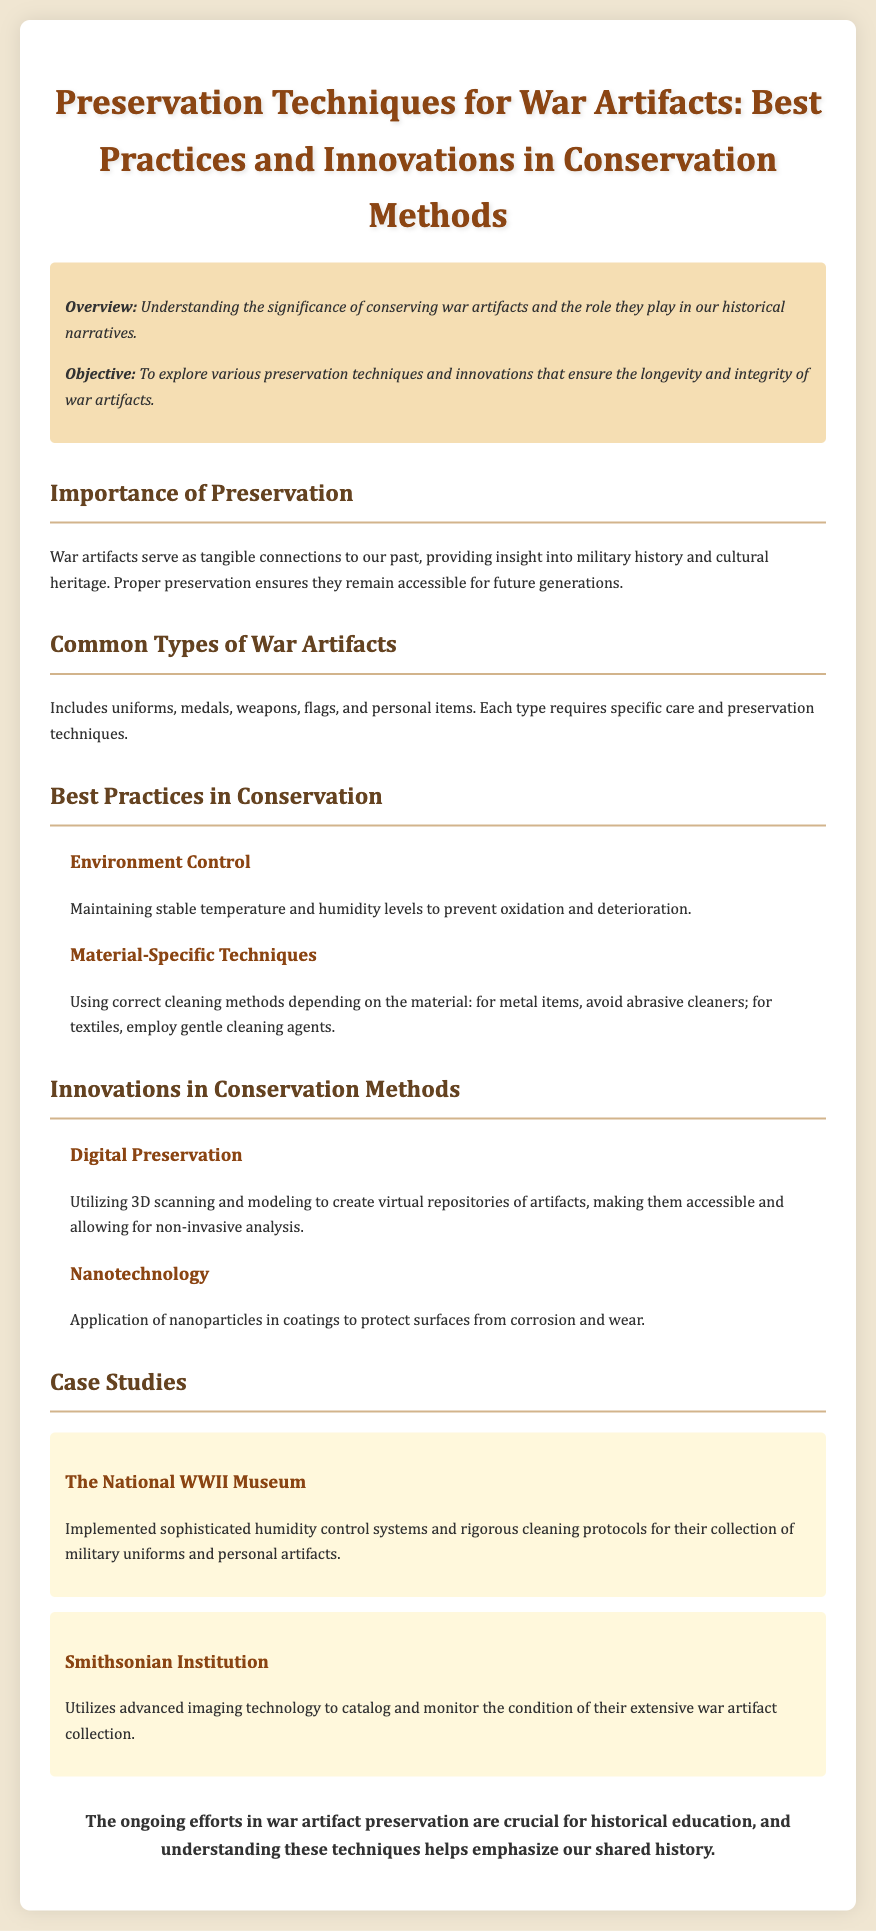What is the objective of the document? The document's objective is to explore various preservation techniques and innovations that ensure the longevity and integrity of war artifacts.
Answer: To explore various preservation techniques and innovations that ensure the longevity and integrity of war artifacts What are common types of war artifacts mentioned? The document lists uniforms, medals, weapons, flags, and personal items as common types of war artifacts.
Answer: Uniforms, medals, weapons, flags, personal items What is a specific method for controlling the environment in artifact preservation? The document mentions maintaining stable temperature and humidity levels to prevent oxidation and deterioration as a specific method.
Answer: Maintaining stable temperature and humidity levels What technique does the Smithsonian Institution use for war artifact monitoring? The document states that the Smithsonian Institution utilizes advanced imaging technology to catalog and monitor the condition of their extensive war artifact collection.
Answer: Advanced imaging technology What application of nanotechnology is discussed in the document? The document discusses the application of nanoparticles in coatings to protect surfaces from corrosion and wear as an innovation in conservation methods.
Answer: Protect surfaces from corrosion and wear What is the primary focus of the case studies section? The case studies section focuses on specific institutions implementing preservation techniques for their collections.
Answer: Specific institutions implementing preservation techniques 